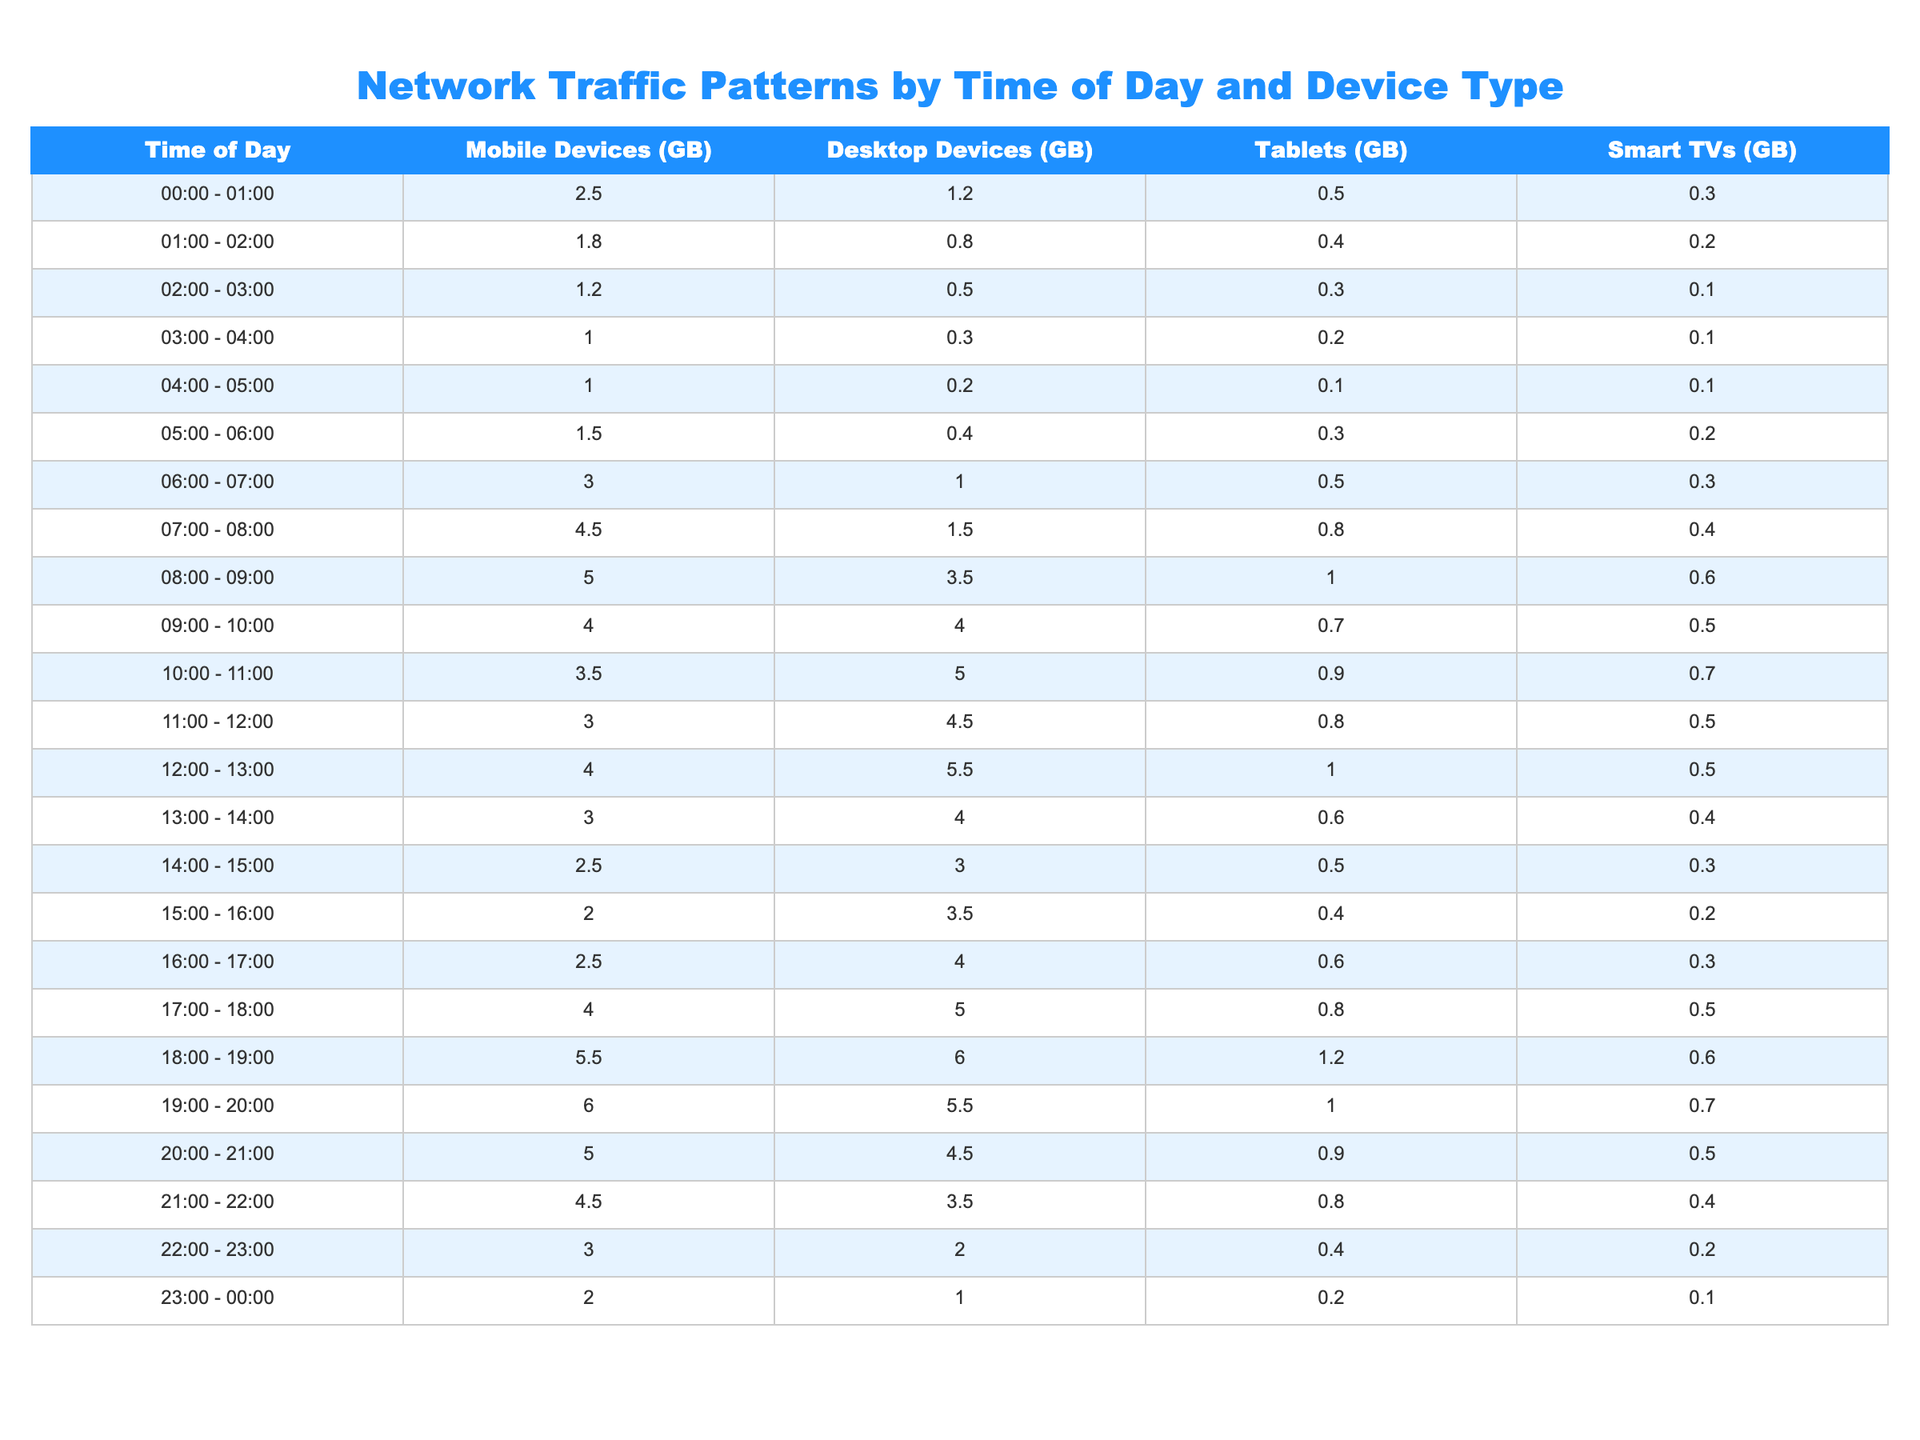What is the maximum network traffic recorded for mobile devices during a single hour? By inspecting the table, the highest value under the "Mobile Devices (GB)" column can be identified. The values range from 1.0 to 6.0, and the maximum is 6.0 recorded between 19:00 - 20:00.
Answer: 6.0 During which time slot did desktop devices observe the least amount of data traffic? By looking across the "Desktop Devices (GB)" column, we can find the minimum value which is 0.2 between the time slots of 04:00 - 05:00.
Answer: 0.2 What is the total data traffic for tablets during the hours of 18:00 - 19:00 and 19:00 - 20:00 combined? First, we sum the values for tablets in those two time slots: 1.2 (18:00 - 19:00) + 1.0 (19:00 - 20:00) = 2.2. Thus, the total data traffic for tablets in those hours is 2.2 GB.
Answer: 2.2 Is there any time slot where mobile device traffic was greater than 5 GB? Checking the "Mobile Devices (GB)" column, we find that the values are 2.5, 1.8, 1.2, 1.0, 1.0, 1.5, 3.0, 4.5, 5.0, and finally 6.0. Indeed, during the time slot 19:00 - 20:00, mobile traffic was 6.0 GB, confirming the statement is true.
Answer: Yes What is the average network traffic for smart TVs across the entire day? To compute the average, we sum up the values for Smart TVs and then divide by the total number of time slots (24 hours). The total for Smart TVs is (0.3 + 0.2 + 0.1 + 0.1 + 0.1 + 0.2 + 0.3 + 0.4 + 0.6 + 0.7 + 0.5 + 0.5 + 0.4 + 0.3 + 0.2 + 0.5 + 0.6 + 0.7 + 0.5 + 0.4 + 0.2 + 0.1) = 8.0. Dividing this by 24 gives an average of approximately 0.33 GB.
Answer: 0.33 During which hour do desktop devices consume the most data? By examining the "Desktop Devices (GB)" column, we observe the highest value is 6.0 during the time slot from 18:00 - 19:00.
Answer: 18:00 - 19:00 What is the difference in network traffic between mobile devices and tablets during the 10:00 - 11:00 hour? The values for that hour are 3.5 GB for mobile devices and 0.9 GB for tablets. The difference is 3.5 - 0.9 = 2.6. Therefore, mobile devices have 2.6 GB more traffic than tablets.
Answer: 2.6 What was the traffic for each device type during the 05:00 - 06:00 hour? Reviewing the row for 05:00 - 06:00, we find the values: Mobile Devices (1.5 GB), Desktop Devices (0.4 GB), Tablets (0.3 GB), Smart TVs (0.2 GB). This gives us the respective traffic for this time slot.
Answer: Mobile: 1.5, Desktop: 0.4, Tablets: 0.3, Smart TVs: 0.2 